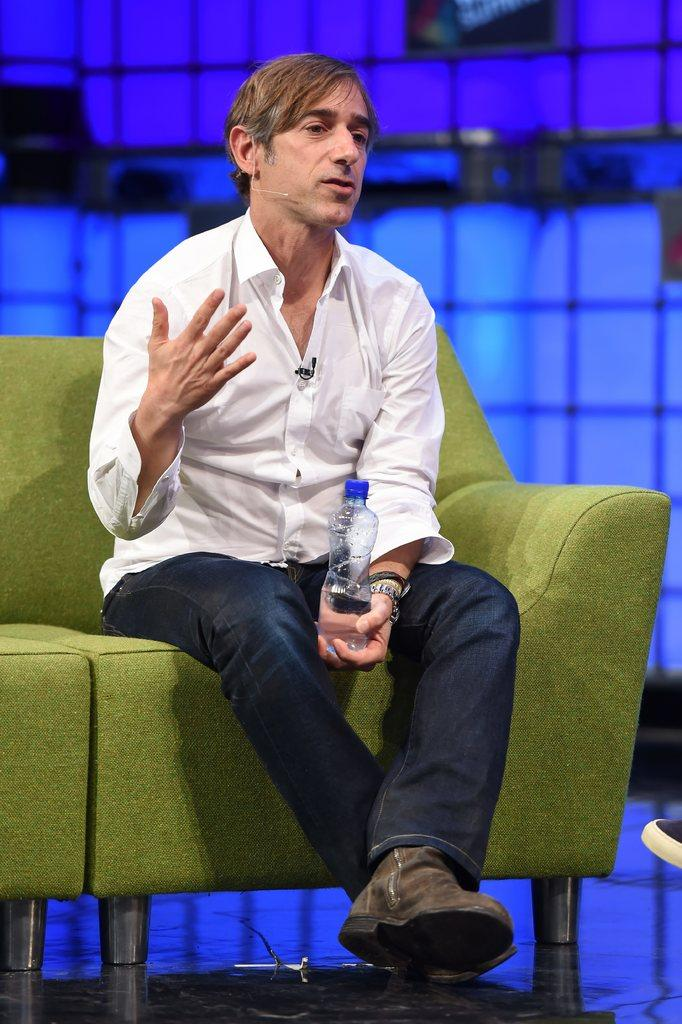Who is present in the image? There is a man in the image. What is the man doing in the image? The man is sitting on a sofa. What is the man holding in the image? The man is holding a bottle. What type of footwear is the man wearing in the image? The man is wearing shoes. What type of surface is visible in the image? The image shows a floor. What government policy is being discussed in the image? There is no indication in the image that a government policy is being discussed. 